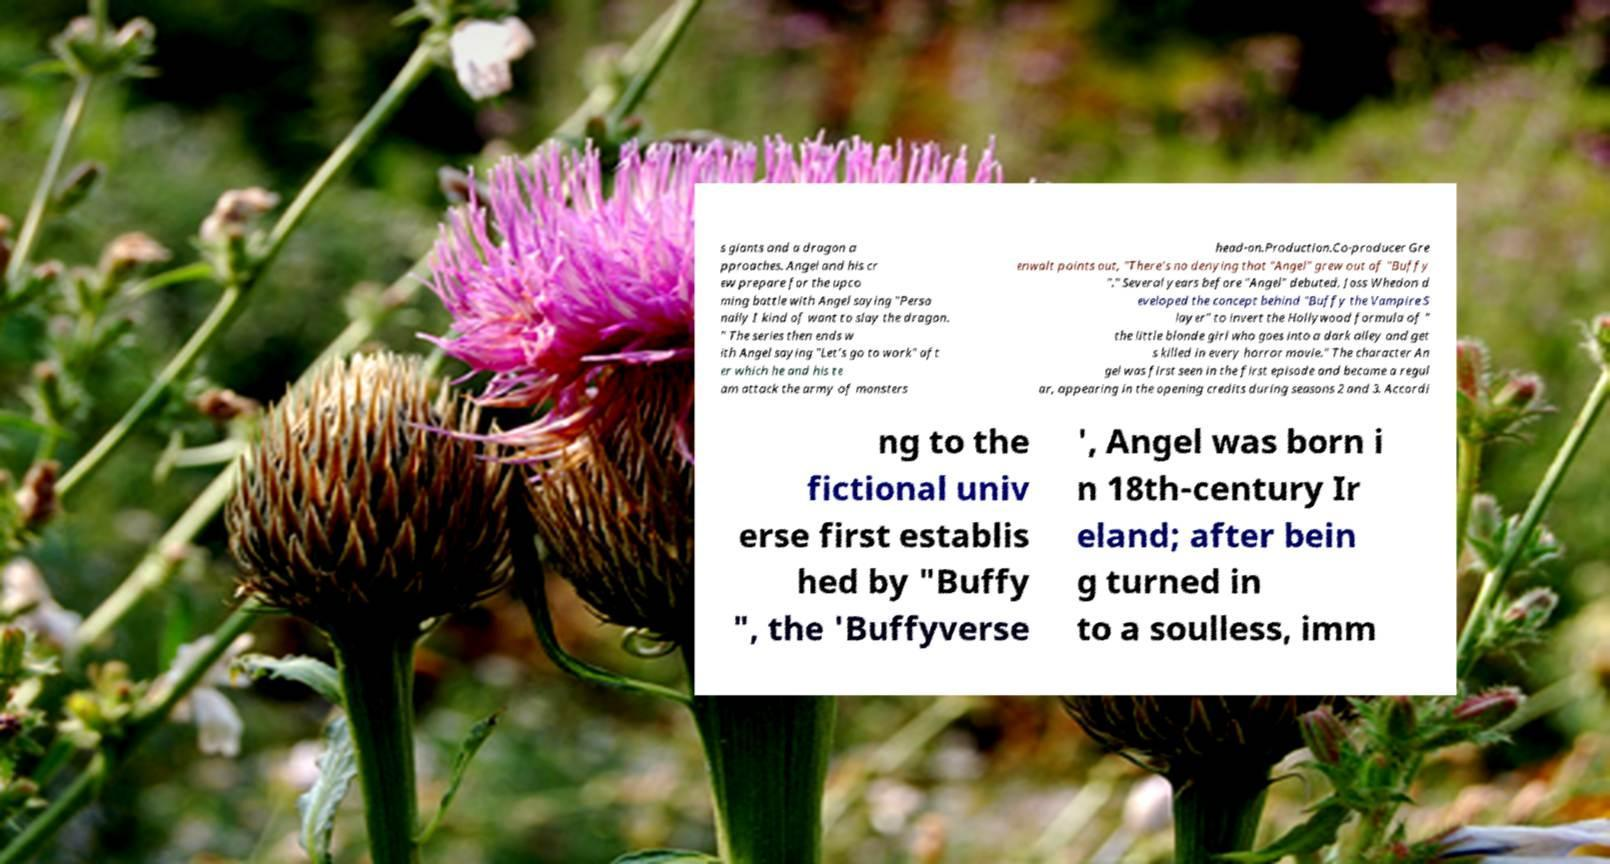Can you accurately transcribe the text from the provided image for me? s giants and a dragon a pproaches. Angel and his cr ew prepare for the upco ming battle with Angel saying "Perso nally I kind of want to slay the dragon. " The series then ends w ith Angel saying "Let's go to work" aft er which he and his te am attack the army of monsters head-on.Production.Co-producer Gre enwalt points out, "There's no denying that "Angel" grew out of "Buffy "." Several years before "Angel" debuted, Joss Whedon d eveloped the concept behind "Buffy the Vampire S layer" to invert the Hollywood formula of " the little blonde girl who goes into a dark alley and get s killed in every horror movie." The character An gel was first seen in the first episode and became a regul ar, appearing in the opening credits during seasons 2 and 3. Accordi ng to the fictional univ erse first establis hed by "Buffy ", the 'Buffyverse ', Angel was born i n 18th-century Ir eland; after bein g turned in to a soulless, imm 